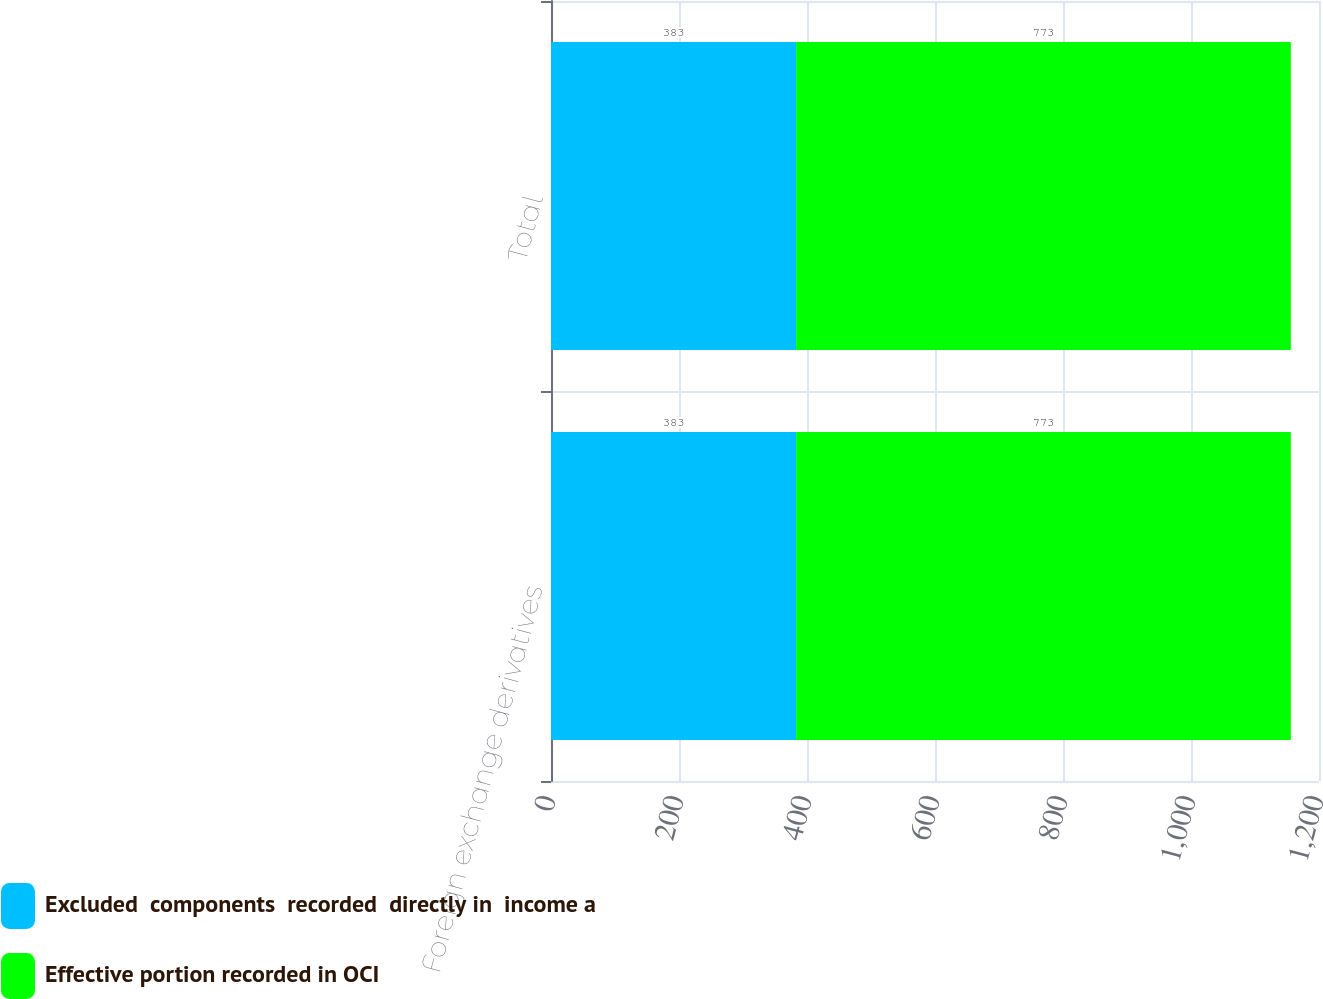Convert chart to OTSL. <chart><loc_0><loc_0><loc_500><loc_500><stacked_bar_chart><ecel><fcel>Foreign exchange derivatives<fcel>Total<nl><fcel>Excluded  components  recorded  directly in  income a<fcel>383<fcel>383<nl><fcel>Effective portion recorded in OCI<fcel>773<fcel>773<nl></chart> 